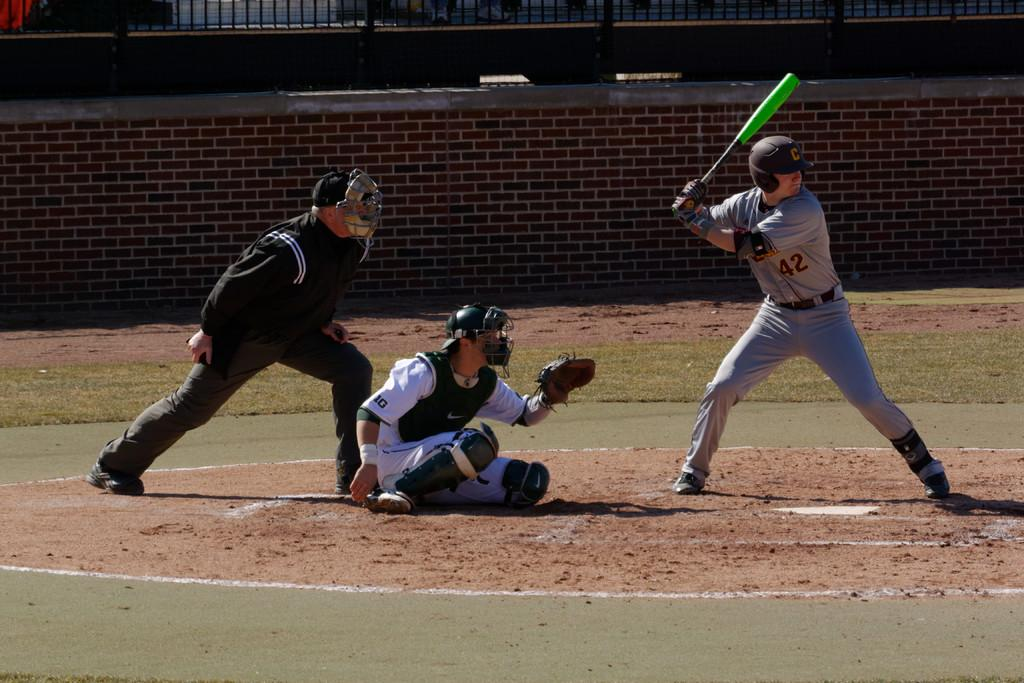<image>
Write a terse but informative summary of the picture. The player 42 is the batter and is about to swing for the ball. 